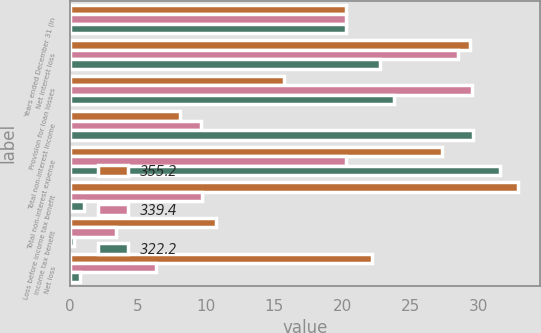<chart> <loc_0><loc_0><loc_500><loc_500><stacked_bar_chart><ecel><fcel>Years ended December 31 (in<fcel>Net interest loss<fcel>Provision for loan losses<fcel>Total non-interest income<fcel>Total non-interest expense<fcel>Loss before income tax benefit<fcel>Income tax benefit<fcel>Net loss<nl><fcel>355.2<fcel>20.3<fcel>29.4<fcel>15.7<fcel>8.1<fcel>27.3<fcel>32.9<fcel>10.7<fcel>22.2<nl><fcel>339.4<fcel>20.3<fcel>28.5<fcel>29.5<fcel>9.6<fcel>20.3<fcel>9.7<fcel>3.4<fcel>6.3<nl><fcel>322.2<fcel>20.3<fcel>22.8<fcel>23.8<fcel>29.6<fcel>31.6<fcel>1<fcel>0.3<fcel>0.7<nl></chart> 